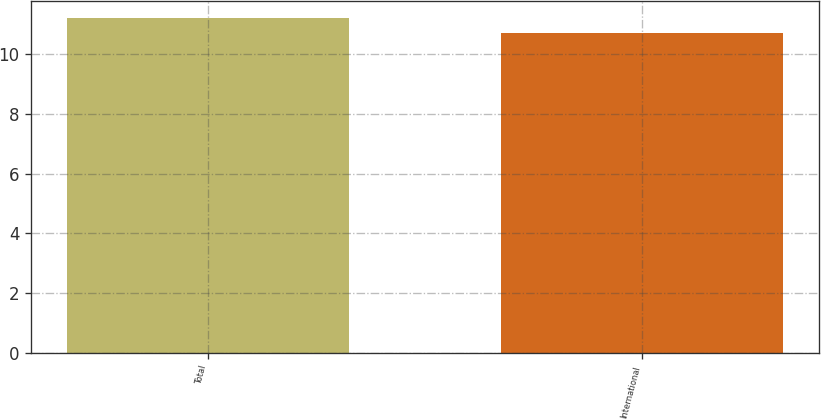Convert chart to OTSL. <chart><loc_0><loc_0><loc_500><loc_500><bar_chart><fcel>Total<fcel>International<nl><fcel>11.2<fcel>10.7<nl></chart> 